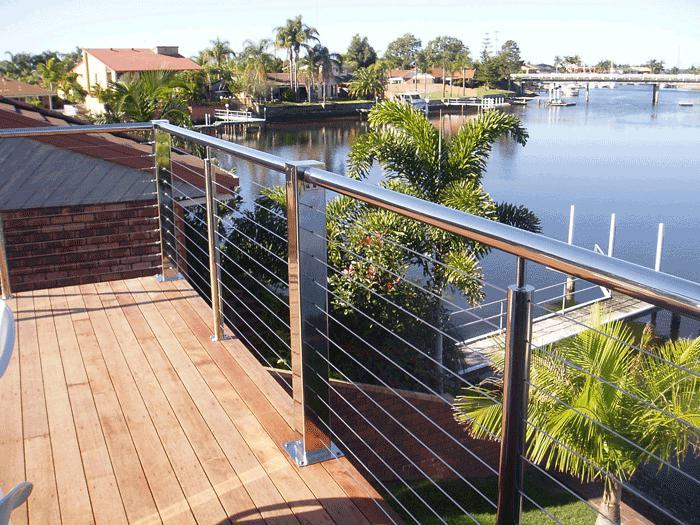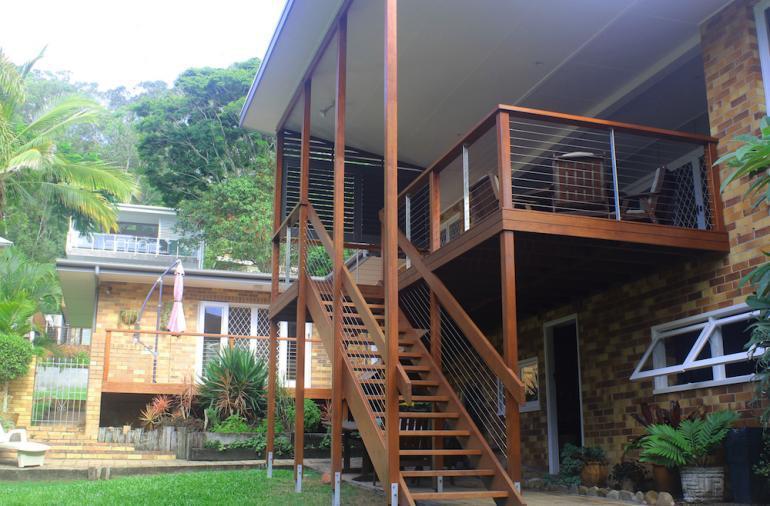The first image is the image on the left, the second image is the image on the right. Assess this claim about the two images: "In at least one image there a is wooden and metal string balcony overlooking the water and trees.". Correct or not? Answer yes or no. Yes. The first image is the image on the left, the second image is the image on the right. Evaluate the accuracy of this statement regarding the images: "The left image shows the corner of a deck with a silver-colored pipe-shaped handrail and thin horizontal metal rods beween upright metal posts.". Is it true? Answer yes or no. Yes. 